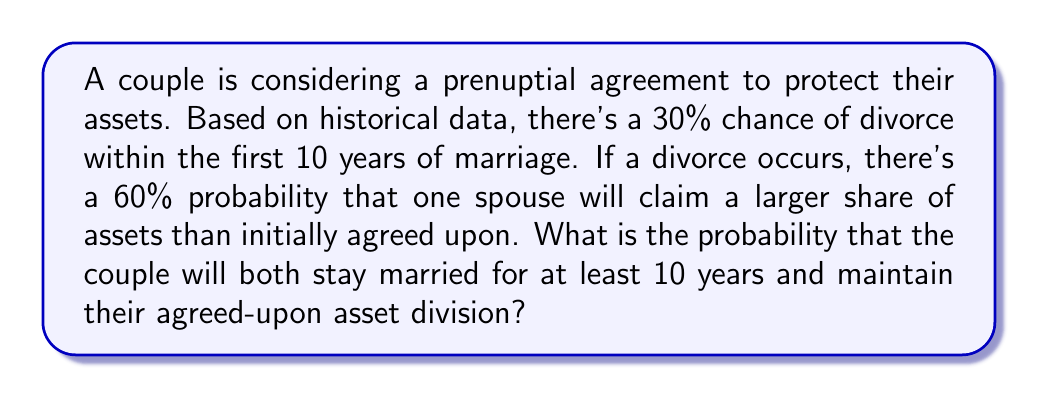Show me your answer to this math problem. Let's approach this step-by-step using probability theory:

1) Let's define our events:
   A: The couple stays married for at least 10 years
   B: The agreed-upon asset division is maintained

2) We're given:
   P(divorce within 10 years) = 0.30
   P(larger asset claim | divorce) = 0.60

3) From this, we can derive:
   P(A) = 1 - P(divorce within 10 years) = 1 - 0.30 = 0.70

4) Now, let's consider P(B):
   P(B) = P(B | A) * P(A) + P(B | not A) * P(not A)

   We know P(A) = 0.70 and P(not A) = 0.30

   If they stay married (A), the asset division is maintained, so P(B | A) = 1

   If they divorce (not A), there's a 40% chance the asset division is maintained:
   P(B | not A) = 1 - P(larger asset claim | divorce) = 1 - 0.60 = 0.40

5) Plugging these into our equation:
   P(B) = 1 * 0.70 + 0.40 * 0.30 = 0.70 + 0.12 = 0.82

6) The question asks for P(A and B), which is:
   P(A and B) = P(A) * P(B | A) = 0.70 * 1 = 0.70

Therefore, the probability that the couple will both stay married for at least 10 years and maintain their agreed-upon asset division is 0.70 or 70%.
Answer: 0.70 